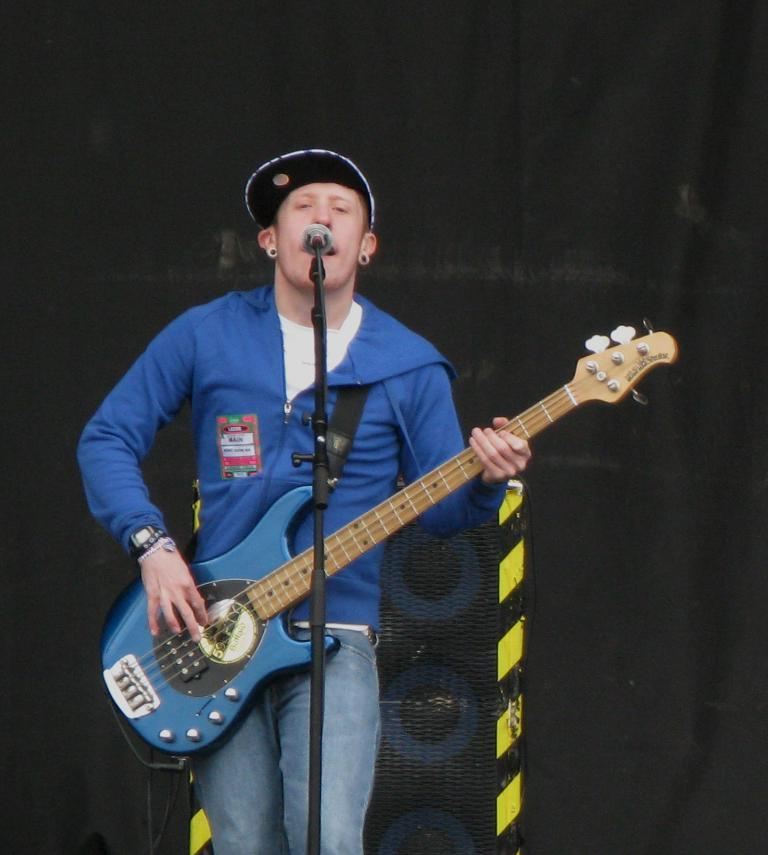What is the person in the image doing? The person is playing a guitar. What is the person wearing in the image? The person is wearing a blue shirt. What object is in front of the person? There is a microphone in front of the person. What can be seen in the background of the image? There is a big speaker in the background of the image. How many flowers are on the person's shirt in the image? There are no flowers visible on the person's shirt in the image. Can you tell me the distance between the person and the duck in the image? There is no duck present in the image. 